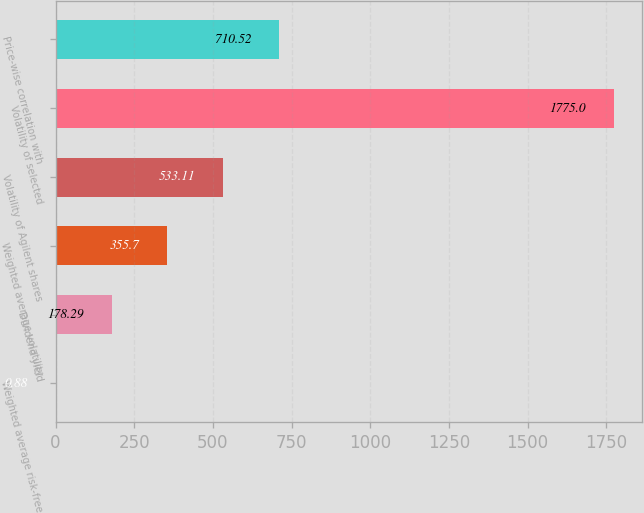Convert chart to OTSL. <chart><loc_0><loc_0><loc_500><loc_500><bar_chart><fcel>Weighted average risk-free<fcel>Dividend yield<fcel>Weighted average volatility<fcel>Volatility of Agilent shares<fcel>Volatility of selected<fcel>Price-wise correlation with<nl><fcel>0.88<fcel>178.29<fcel>355.7<fcel>533.11<fcel>1775<fcel>710.52<nl></chart> 